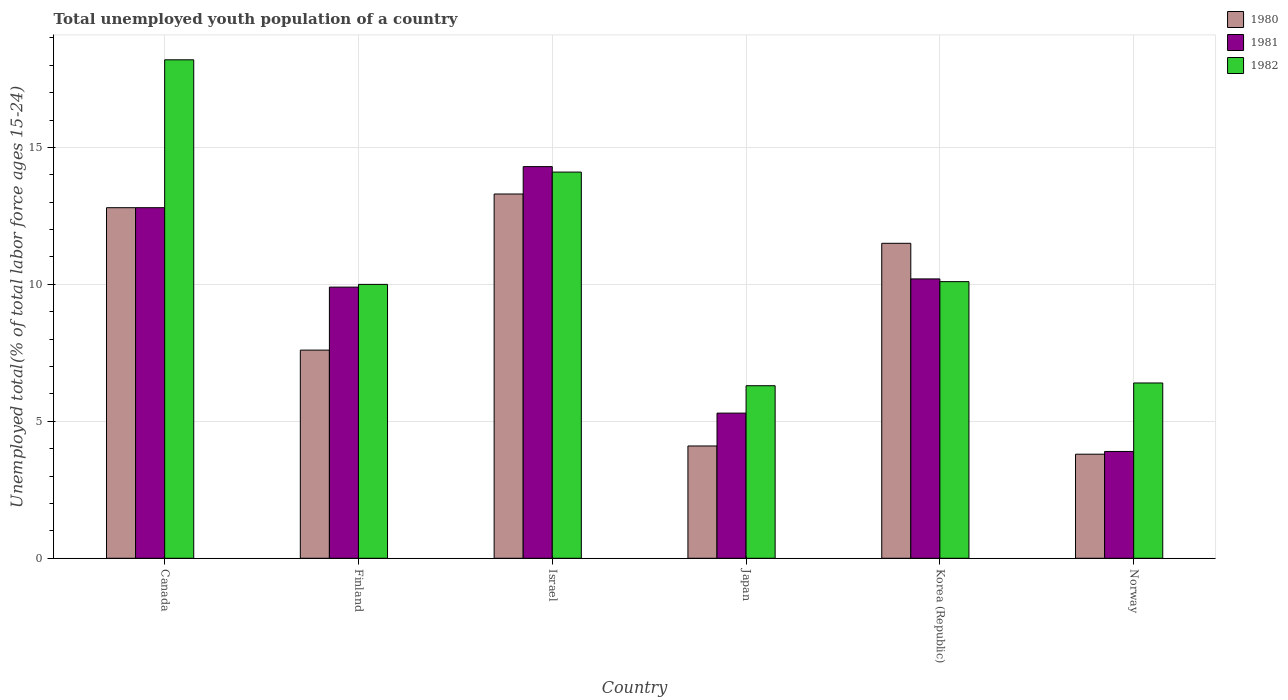How many different coloured bars are there?
Give a very brief answer. 3. How many groups of bars are there?
Offer a terse response. 6. Are the number of bars per tick equal to the number of legend labels?
Provide a succinct answer. Yes. Are the number of bars on each tick of the X-axis equal?
Give a very brief answer. Yes. How many bars are there on the 3rd tick from the left?
Keep it short and to the point. 3. How many bars are there on the 4th tick from the right?
Provide a succinct answer. 3. In how many cases, is the number of bars for a given country not equal to the number of legend labels?
Keep it short and to the point. 0. What is the percentage of total unemployed youth population of a country in 1982 in Canada?
Provide a succinct answer. 18.2. Across all countries, what is the maximum percentage of total unemployed youth population of a country in 1980?
Give a very brief answer. 13.3. Across all countries, what is the minimum percentage of total unemployed youth population of a country in 1981?
Your answer should be compact. 3.9. In which country was the percentage of total unemployed youth population of a country in 1981 minimum?
Offer a terse response. Norway. What is the total percentage of total unemployed youth population of a country in 1980 in the graph?
Ensure brevity in your answer.  53.1. What is the difference between the percentage of total unemployed youth population of a country in 1980 in Finland and that in Israel?
Provide a short and direct response. -5.7. What is the difference between the percentage of total unemployed youth population of a country in 1981 in Norway and the percentage of total unemployed youth population of a country in 1982 in Israel?
Provide a short and direct response. -10.2. What is the average percentage of total unemployed youth population of a country in 1981 per country?
Your response must be concise. 9.4. In how many countries, is the percentage of total unemployed youth population of a country in 1980 greater than 16 %?
Your answer should be very brief. 0. What is the ratio of the percentage of total unemployed youth population of a country in 1982 in Israel to that in Korea (Republic)?
Keep it short and to the point. 1.4. Is the difference between the percentage of total unemployed youth population of a country in 1980 in Israel and Norway greater than the difference between the percentage of total unemployed youth population of a country in 1981 in Israel and Norway?
Your answer should be compact. No. What is the difference between the highest and the second highest percentage of total unemployed youth population of a country in 1982?
Your answer should be compact. 8.1. What is the difference between the highest and the lowest percentage of total unemployed youth population of a country in 1982?
Make the answer very short. 11.9. Is the sum of the percentage of total unemployed youth population of a country in 1982 in Finland and Norway greater than the maximum percentage of total unemployed youth population of a country in 1980 across all countries?
Offer a terse response. Yes. What does the 2nd bar from the left in Korea (Republic) represents?
Give a very brief answer. 1981. Are the values on the major ticks of Y-axis written in scientific E-notation?
Give a very brief answer. No. Does the graph contain grids?
Your answer should be very brief. Yes. Where does the legend appear in the graph?
Give a very brief answer. Top right. What is the title of the graph?
Ensure brevity in your answer.  Total unemployed youth population of a country. What is the label or title of the Y-axis?
Make the answer very short. Unemployed total(% of total labor force ages 15-24). What is the Unemployed total(% of total labor force ages 15-24) of 1980 in Canada?
Keep it short and to the point. 12.8. What is the Unemployed total(% of total labor force ages 15-24) of 1981 in Canada?
Your answer should be very brief. 12.8. What is the Unemployed total(% of total labor force ages 15-24) of 1982 in Canada?
Offer a very short reply. 18.2. What is the Unemployed total(% of total labor force ages 15-24) of 1980 in Finland?
Your answer should be compact. 7.6. What is the Unemployed total(% of total labor force ages 15-24) in 1981 in Finland?
Provide a short and direct response. 9.9. What is the Unemployed total(% of total labor force ages 15-24) in 1980 in Israel?
Offer a very short reply. 13.3. What is the Unemployed total(% of total labor force ages 15-24) in 1981 in Israel?
Ensure brevity in your answer.  14.3. What is the Unemployed total(% of total labor force ages 15-24) in 1982 in Israel?
Keep it short and to the point. 14.1. What is the Unemployed total(% of total labor force ages 15-24) of 1980 in Japan?
Provide a succinct answer. 4.1. What is the Unemployed total(% of total labor force ages 15-24) in 1981 in Japan?
Keep it short and to the point. 5.3. What is the Unemployed total(% of total labor force ages 15-24) of 1982 in Japan?
Ensure brevity in your answer.  6.3. What is the Unemployed total(% of total labor force ages 15-24) of 1981 in Korea (Republic)?
Offer a very short reply. 10.2. What is the Unemployed total(% of total labor force ages 15-24) of 1982 in Korea (Republic)?
Keep it short and to the point. 10.1. What is the Unemployed total(% of total labor force ages 15-24) of 1980 in Norway?
Offer a very short reply. 3.8. What is the Unemployed total(% of total labor force ages 15-24) in 1981 in Norway?
Your answer should be very brief. 3.9. What is the Unemployed total(% of total labor force ages 15-24) in 1982 in Norway?
Provide a succinct answer. 6.4. Across all countries, what is the maximum Unemployed total(% of total labor force ages 15-24) in 1980?
Provide a short and direct response. 13.3. Across all countries, what is the maximum Unemployed total(% of total labor force ages 15-24) of 1981?
Ensure brevity in your answer.  14.3. Across all countries, what is the maximum Unemployed total(% of total labor force ages 15-24) of 1982?
Keep it short and to the point. 18.2. Across all countries, what is the minimum Unemployed total(% of total labor force ages 15-24) in 1980?
Provide a short and direct response. 3.8. Across all countries, what is the minimum Unemployed total(% of total labor force ages 15-24) of 1981?
Give a very brief answer. 3.9. Across all countries, what is the minimum Unemployed total(% of total labor force ages 15-24) of 1982?
Provide a succinct answer. 6.3. What is the total Unemployed total(% of total labor force ages 15-24) of 1980 in the graph?
Offer a terse response. 53.1. What is the total Unemployed total(% of total labor force ages 15-24) in 1981 in the graph?
Give a very brief answer. 56.4. What is the total Unemployed total(% of total labor force ages 15-24) in 1982 in the graph?
Your response must be concise. 65.1. What is the difference between the Unemployed total(% of total labor force ages 15-24) in 1980 in Canada and that in Finland?
Keep it short and to the point. 5.2. What is the difference between the Unemployed total(% of total labor force ages 15-24) in 1981 in Canada and that in Finland?
Your answer should be compact. 2.9. What is the difference between the Unemployed total(% of total labor force ages 15-24) in 1980 in Canada and that in Israel?
Offer a very short reply. -0.5. What is the difference between the Unemployed total(% of total labor force ages 15-24) of 1981 in Canada and that in Israel?
Your response must be concise. -1.5. What is the difference between the Unemployed total(% of total labor force ages 15-24) of 1980 in Canada and that in Japan?
Make the answer very short. 8.7. What is the difference between the Unemployed total(% of total labor force ages 15-24) of 1982 in Canada and that in Japan?
Provide a succinct answer. 11.9. What is the difference between the Unemployed total(% of total labor force ages 15-24) in 1980 in Canada and that in Korea (Republic)?
Your answer should be very brief. 1.3. What is the difference between the Unemployed total(% of total labor force ages 15-24) in 1981 in Canada and that in Korea (Republic)?
Provide a succinct answer. 2.6. What is the difference between the Unemployed total(% of total labor force ages 15-24) of 1982 in Canada and that in Norway?
Provide a succinct answer. 11.8. What is the difference between the Unemployed total(% of total labor force ages 15-24) in 1980 in Finland and that in Israel?
Provide a succinct answer. -5.7. What is the difference between the Unemployed total(% of total labor force ages 15-24) of 1982 in Finland and that in Israel?
Give a very brief answer. -4.1. What is the difference between the Unemployed total(% of total labor force ages 15-24) of 1980 in Finland and that in Japan?
Your response must be concise. 3.5. What is the difference between the Unemployed total(% of total labor force ages 15-24) in 1980 in Finland and that in Norway?
Provide a succinct answer. 3.8. What is the difference between the Unemployed total(% of total labor force ages 15-24) of 1982 in Finland and that in Norway?
Keep it short and to the point. 3.6. What is the difference between the Unemployed total(% of total labor force ages 15-24) of 1980 in Israel and that in Japan?
Give a very brief answer. 9.2. What is the difference between the Unemployed total(% of total labor force ages 15-24) of 1981 in Israel and that in Japan?
Give a very brief answer. 9. What is the difference between the Unemployed total(% of total labor force ages 15-24) of 1982 in Israel and that in Japan?
Give a very brief answer. 7.8. What is the difference between the Unemployed total(% of total labor force ages 15-24) of 1981 in Israel and that in Korea (Republic)?
Provide a succinct answer. 4.1. What is the difference between the Unemployed total(% of total labor force ages 15-24) in 1982 in Israel and that in Korea (Republic)?
Provide a succinct answer. 4. What is the difference between the Unemployed total(% of total labor force ages 15-24) of 1982 in Israel and that in Norway?
Give a very brief answer. 7.7. What is the difference between the Unemployed total(% of total labor force ages 15-24) in 1982 in Japan and that in Korea (Republic)?
Make the answer very short. -3.8. What is the difference between the Unemployed total(% of total labor force ages 15-24) of 1980 in Japan and that in Norway?
Give a very brief answer. 0.3. What is the difference between the Unemployed total(% of total labor force ages 15-24) of 1981 in Japan and that in Norway?
Keep it short and to the point. 1.4. What is the difference between the Unemployed total(% of total labor force ages 15-24) of 1981 in Korea (Republic) and that in Norway?
Offer a terse response. 6.3. What is the difference between the Unemployed total(% of total labor force ages 15-24) of 1980 in Canada and the Unemployed total(% of total labor force ages 15-24) of 1982 in Finland?
Your answer should be compact. 2.8. What is the difference between the Unemployed total(% of total labor force ages 15-24) in 1981 in Canada and the Unemployed total(% of total labor force ages 15-24) in 1982 in Finland?
Your answer should be compact. 2.8. What is the difference between the Unemployed total(% of total labor force ages 15-24) in 1981 in Canada and the Unemployed total(% of total labor force ages 15-24) in 1982 in Israel?
Offer a terse response. -1.3. What is the difference between the Unemployed total(% of total labor force ages 15-24) of 1980 in Canada and the Unemployed total(% of total labor force ages 15-24) of 1981 in Japan?
Offer a very short reply. 7.5. What is the difference between the Unemployed total(% of total labor force ages 15-24) of 1980 in Canada and the Unemployed total(% of total labor force ages 15-24) of 1982 in Japan?
Your response must be concise. 6.5. What is the difference between the Unemployed total(% of total labor force ages 15-24) of 1981 in Canada and the Unemployed total(% of total labor force ages 15-24) of 1982 in Norway?
Make the answer very short. 6.4. What is the difference between the Unemployed total(% of total labor force ages 15-24) in 1980 in Finland and the Unemployed total(% of total labor force ages 15-24) in 1981 in Israel?
Offer a very short reply. -6.7. What is the difference between the Unemployed total(% of total labor force ages 15-24) of 1981 in Finland and the Unemployed total(% of total labor force ages 15-24) of 1982 in Israel?
Your answer should be compact. -4.2. What is the difference between the Unemployed total(% of total labor force ages 15-24) in 1980 in Finland and the Unemployed total(% of total labor force ages 15-24) in 1981 in Japan?
Your answer should be very brief. 2.3. What is the difference between the Unemployed total(% of total labor force ages 15-24) in 1980 in Finland and the Unemployed total(% of total labor force ages 15-24) in 1981 in Korea (Republic)?
Offer a terse response. -2.6. What is the difference between the Unemployed total(% of total labor force ages 15-24) of 1980 in Finland and the Unemployed total(% of total labor force ages 15-24) of 1982 in Korea (Republic)?
Your answer should be very brief. -2.5. What is the difference between the Unemployed total(% of total labor force ages 15-24) of 1981 in Finland and the Unemployed total(% of total labor force ages 15-24) of 1982 in Korea (Republic)?
Keep it short and to the point. -0.2. What is the difference between the Unemployed total(% of total labor force ages 15-24) in 1980 in Finland and the Unemployed total(% of total labor force ages 15-24) in 1982 in Norway?
Your answer should be very brief. 1.2. What is the difference between the Unemployed total(% of total labor force ages 15-24) of 1981 in Finland and the Unemployed total(% of total labor force ages 15-24) of 1982 in Norway?
Your answer should be very brief. 3.5. What is the difference between the Unemployed total(% of total labor force ages 15-24) of 1981 in Israel and the Unemployed total(% of total labor force ages 15-24) of 1982 in Japan?
Provide a short and direct response. 8. What is the difference between the Unemployed total(% of total labor force ages 15-24) in 1980 in Israel and the Unemployed total(% of total labor force ages 15-24) in 1981 in Korea (Republic)?
Your response must be concise. 3.1. What is the difference between the Unemployed total(% of total labor force ages 15-24) in 1980 in Israel and the Unemployed total(% of total labor force ages 15-24) in 1981 in Norway?
Offer a very short reply. 9.4. What is the difference between the Unemployed total(% of total labor force ages 15-24) in 1980 in Japan and the Unemployed total(% of total labor force ages 15-24) in 1981 in Korea (Republic)?
Offer a very short reply. -6.1. What is the difference between the Unemployed total(% of total labor force ages 15-24) of 1981 in Japan and the Unemployed total(% of total labor force ages 15-24) of 1982 in Korea (Republic)?
Provide a short and direct response. -4.8. What is the difference between the Unemployed total(% of total labor force ages 15-24) of 1980 in Japan and the Unemployed total(% of total labor force ages 15-24) of 1982 in Norway?
Provide a succinct answer. -2.3. What is the difference between the Unemployed total(% of total labor force ages 15-24) of 1980 in Korea (Republic) and the Unemployed total(% of total labor force ages 15-24) of 1982 in Norway?
Your response must be concise. 5.1. What is the difference between the Unemployed total(% of total labor force ages 15-24) of 1981 in Korea (Republic) and the Unemployed total(% of total labor force ages 15-24) of 1982 in Norway?
Make the answer very short. 3.8. What is the average Unemployed total(% of total labor force ages 15-24) of 1980 per country?
Keep it short and to the point. 8.85. What is the average Unemployed total(% of total labor force ages 15-24) of 1981 per country?
Ensure brevity in your answer.  9.4. What is the average Unemployed total(% of total labor force ages 15-24) of 1982 per country?
Ensure brevity in your answer.  10.85. What is the difference between the Unemployed total(% of total labor force ages 15-24) of 1980 and Unemployed total(% of total labor force ages 15-24) of 1982 in Canada?
Make the answer very short. -5.4. What is the difference between the Unemployed total(% of total labor force ages 15-24) of 1980 and Unemployed total(% of total labor force ages 15-24) of 1981 in Finland?
Your response must be concise. -2.3. What is the difference between the Unemployed total(% of total labor force ages 15-24) of 1980 and Unemployed total(% of total labor force ages 15-24) of 1982 in Finland?
Ensure brevity in your answer.  -2.4. What is the difference between the Unemployed total(% of total labor force ages 15-24) in 1981 and Unemployed total(% of total labor force ages 15-24) in 1982 in Finland?
Offer a very short reply. -0.1. What is the difference between the Unemployed total(% of total labor force ages 15-24) of 1980 and Unemployed total(% of total labor force ages 15-24) of 1982 in Israel?
Provide a short and direct response. -0.8. What is the difference between the Unemployed total(% of total labor force ages 15-24) in 1980 and Unemployed total(% of total labor force ages 15-24) in 1981 in Japan?
Provide a short and direct response. -1.2. What is the difference between the Unemployed total(% of total labor force ages 15-24) of 1980 and Unemployed total(% of total labor force ages 15-24) of 1982 in Japan?
Your response must be concise. -2.2. What is the difference between the Unemployed total(% of total labor force ages 15-24) in 1980 and Unemployed total(% of total labor force ages 15-24) in 1981 in Korea (Republic)?
Keep it short and to the point. 1.3. What is the difference between the Unemployed total(% of total labor force ages 15-24) in 1981 and Unemployed total(% of total labor force ages 15-24) in 1982 in Korea (Republic)?
Offer a terse response. 0.1. What is the difference between the Unemployed total(% of total labor force ages 15-24) of 1980 and Unemployed total(% of total labor force ages 15-24) of 1982 in Norway?
Your answer should be very brief. -2.6. What is the difference between the Unemployed total(% of total labor force ages 15-24) in 1981 and Unemployed total(% of total labor force ages 15-24) in 1982 in Norway?
Your answer should be very brief. -2.5. What is the ratio of the Unemployed total(% of total labor force ages 15-24) of 1980 in Canada to that in Finland?
Provide a short and direct response. 1.68. What is the ratio of the Unemployed total(% of total labor force ages 15-24) in 1981 in Canada to that in Finland?
Your answer should be compact. 1.29. What is the ratio of the Unemployed total(% of total labor force ages 15-24) in 1982 in Canada to that in Finland?
Keep it short and to the point. 1.82. What is the ratio of the Unemployed total(% of total labor force ages 15-24) of 1980 in Canada to that in Israel?
Offer a terse response. 0.96. What is the ratio of the Unemployed total(% of total labor force ages 15-24) in 1981 in Canada to that in Israel?
Offer a terse response. 0.9. What is the ratio of the Unemployed total(% of total labor force ages 15-24) of 1982 in Canada to that in Israel?
Offer a very short reply. 1.29. What is the ratio of the Unemployed total(% of total labor force ages 15-24) in 1980 in Canada to that in Japan?
Make the answer very short. 3.12. What is the ratio of the Unemployed total(% of total labor force ages 15-24) in 1981 in Canada to that in Japan?
Your answer should be very brief. 2.42. What is the ratio of the Unemployed total(% of total labor force ages 15-24) of 1982 in Canada to that in Japan?
Offer a very short reply. 2.89. What is the ratio of the Unemployed total(% of total labor force ages 15-24) in 1980 in Canada to that in Korea (Republic)?
Provide a short and direct response. 1.11. What is the ratio of the Unemployed total(% of total labor force ages 15-24) in 1981 in Canada to that in Korea (Republic)?
Make the answer very short. 1.25. What is the ratio of the Unemployed total(% of total labor force ages 15-24) in 1982 in Canada to that in Korea (Republic)?
Provide a succinct answer. 1.8. What is the ratio of the Unemployed total(% of total labor force ages 15-24) in 1980 in Canada to that in Norway?
Keep it short and to the point. 3.37. What is the ratio of the Unemployed total(% of total labor force ages 15-24) of 1981 in Canada to that in Norway?
Keep it short and to the point. 3.28. What is the ratio of the Unemployed total(% of total labor force ages 15-24) in 1982 in Canada to that in Norway?
Offer a terse response. 2.84. What is the ratio of the Unemployed total(% of total labor force ages 15-24) of 1980 in Finland to that in Israel?
Make the answer very short. 0.57. What is the ratio of the Unemployed total(% of total labor force ages 15-24) in 1981 in Finland to that in Israel?
Provide a succinct answer. 0.69. What is the ratio of the Unemployed total(% of total labor force ages 15-24) of 1982 in Finland to that in Israel?
Your response must be concise. 0.71. What is the ratio of the Unemployed total(% of total labor force ages 15-24) in 1980 in Finland to that in Japan?
Your answer should be very brief. 1.85. What is the ratio of the Unemployed total(% of total labor force ages 15-24) of 1981 in Finland to that in Japan?
Provide a short and direct response. 1.87. What is the ratio of the Unemployed total(% of total labor force ages 15-24) of 1982 in Finland to that in Japan?
Offer a very short reply. 1.59. What is the ratio of the Unemployed total(% of total labor force ages 15-24) of 1980 in Finland to that in Korea (Republic)?
Offer a terse response. 0.66. What is the ratio of the Unemployed total(% of total labor force ages 15-24) in 1981 in Finland to that in Korea (Republic)?
Your response must be concise. 0.97. What is the ratio of the Unemployed total(% of total labor force ages 15-24) in 1980 in Finland to that in Norway?
Provide a succinct answer. 2. What is the ratio of the Unemployed total(% of total labor force ages 15-24) in 1981 in Finland to that in Norway?
Make the answer very short. 2.54. What is the ratio of the Unemployed total(% of total labor force ages 15-24) in 1982 in Finland to that in Norway?
Provide a short and direct response. 1.56. What is the ratio of the Unemployed total(% of total labor force ages 15-24) of 1980 in Israel to that in Japan?
Give a very brief answer. 3.24. What is the ratio of the Unemployed total(% of total labor force ages 15-24) of 1981 in Israel to that in Japan?
Offer a terse response. 2.7. What is the ratio of the Unemployed total(% of total labor force ages 15-24) in 1982 in Israel to that in Japan?
Your answer should be very brief. 2.24. What is the ratio of the Unemployed total(% of total labor force ages 15-24) of 1980 in Israel to that in Korea (Republic)?
Give a very brief answer. 1.16. What is the ratio of the Unemployed total(% of total labor force ages 15-24) of 1981 in Israel to that in Korea (Republic)?
Keep it short and to the point. 1.4. What is the ratio of the Unemployed total(% of total labor force ages 15-24) in 1982 in Israel to that in Korea (Republic)?
Your response must be concise. 1.4. What is the ratio of the Unemployed total(% of total labor force ages 15-24) of 1980 in Israel to that in Norway?
Keep it short and to the point. 3.5. What is the ratio of the Unemployed total(% of total labor force ages 15-24) of 1981 in Israel to that in Norway?
Keep it short and to the point. 3.67. What is the ratio of the Unemployed total(% of total labor force ages 15-24) of 1982 in Israel to that in Norway?
Keep it short and to the point. 2.2. What is the ratio of the Unemployed total(% of total labor force ages 15-24) in 1980 in Japan to that in Korea (Republic)?
Provide a short and direct response. 0.36. What is the ratio of the Unemployed total(% of total labor force ages 15-24) in 1981 in Japan to that in Korea (Republic)?
Your answer should be very brief. 0.52. What is the ratio of the Unemployed total(% of total labor force ages 15-24) of 1982 in Japan to that in Korea (Republic)?
Keep it short and to the point. 0.62. What is the ratio of the Unemployed total(% of total labor force ages 15-24) of 1980 in Japan to that in Norway?
Your answer should be compact. 1.08. What is the ratio of the Unemployed total(% of total labor force ages 15-24) of 1981 in Japan to that in Norway?
Make the answer very short. 1.36. What is the ratio of the Unemployed total(% of total labor force ages 15-24) in 1982 in Japan to that in Norway?
Provide a short and direct response. 0.98. What is the ratio of the Unemployed total(% of total labor force ages 15-24) of 1980 in Korea (Republic) to that in Norway?
Offer a terse response. 3.03. What is the ratio of the Unemployed total(% of total labor force ages 15-24) in 1981 in Korea (Republic) to that in Norway?
Provide a short and direct response. 2.62. What is the ratio of the Unemployed total(% of total labor force ages 15-24) in 1982 in Korea (Republic) to that in Norway?
Offer a very short reply. 1.58. What is the difference between the highest and the second highest Unemployed total(% of total labor force ages 15-24) of 1980?
Provide a short and direct response. 0.5. What is the difference between the highest and the second highest Unemployed total(% of total labor force ages 15-24) of 1982?
Your answer should be compact. 4.1. What is the difference between the highest and the lowest Unemployed total(% of total labor force ages 15-24) in 1982?
Keep it short and to the point. 11.9. 